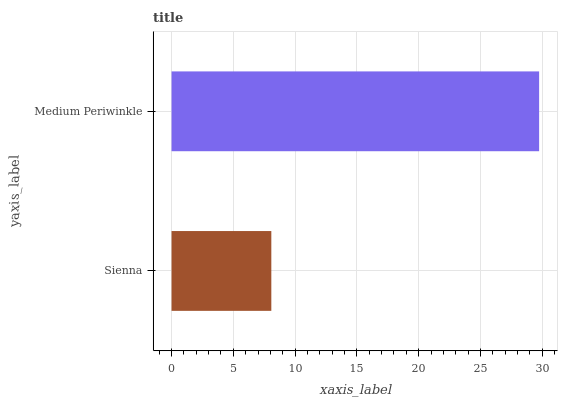Is Sienna the minimum?
Answer yes or no. Yes. Is Medium Periwinkle the maximum?
Answer yes or no. Yes. Is Medium Periwinkle the minimum?
Answer yes or no. No. Is Medium Periwinkle greater than Sienna?
Answer yes or no. Yes. Is Sienna less than Medium Periwinkle?
Answer yes or no. Yes. Is Sienna greater than Medium Periwinkle?
Answer yes or no. No. Is Medium Periwinkle less than Sienna?
Answer yes or no. No. Is Medium Periwinkle the high median?
Answer yes or no. Yes. Is Sienna the low median?
Answer yes or no. Yes. Is Sienna the high median?
Answer yes or no. No. Is Medium Periwinkle the low median?
Answer yes or no. No. 